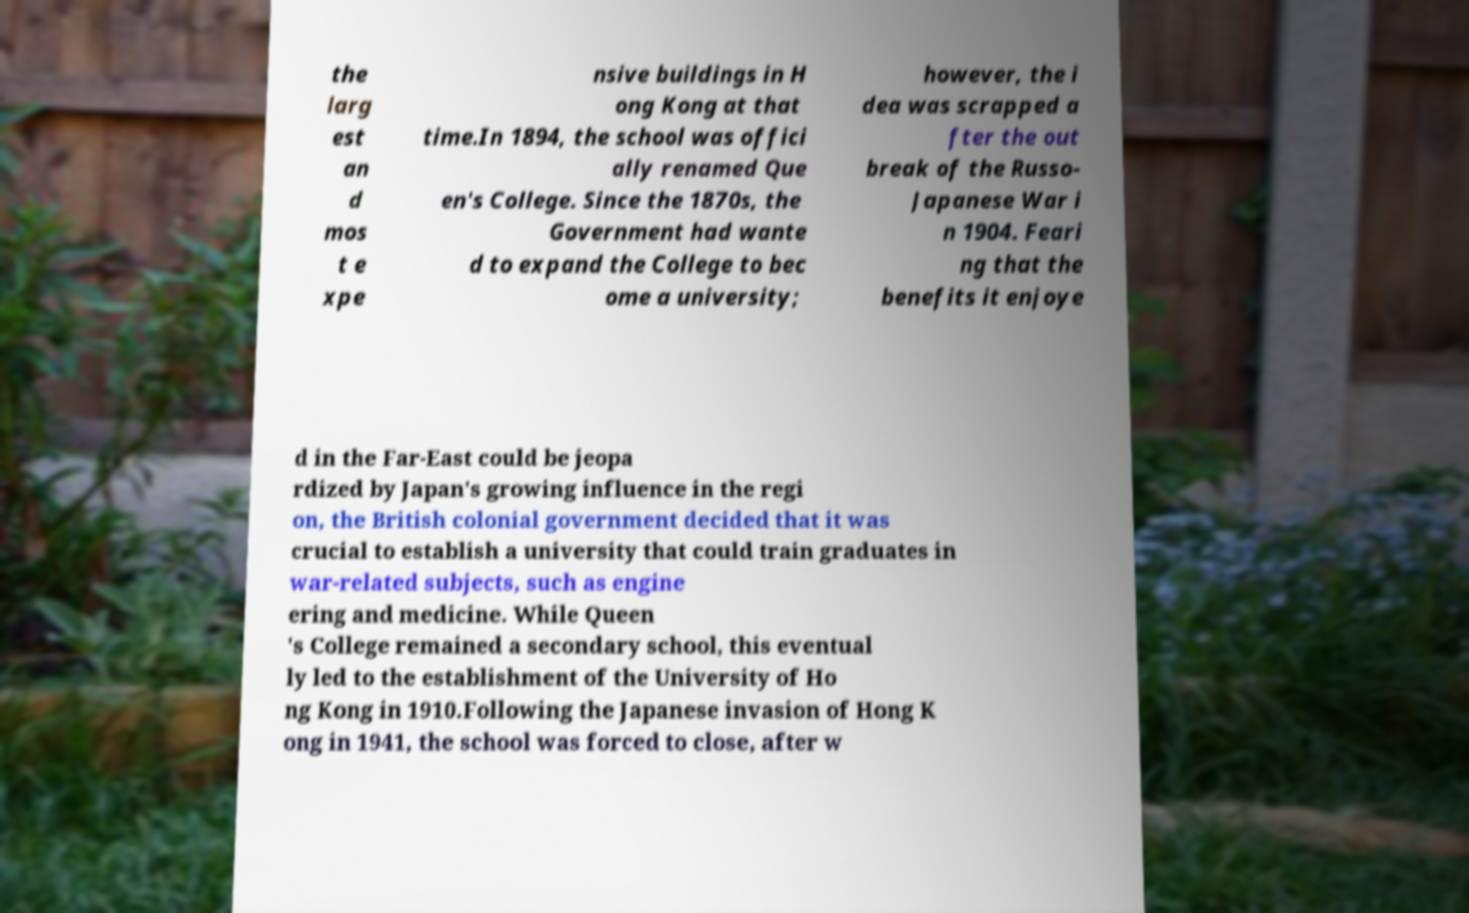What messages or text are displayed in this image? I need them in a readable, typed format. the larg est an d mos t e xpe nsive buildings in H ong Kong at that time.In 1894, the school was offici ally renamed Que en's College. Since the 1870s, the Government had wante d to expand the College to bec ome a university; however, the i dea was scrapped a fter the out break of the Russo- Japanese War i n 1904. Feari ng that the benefits it enjoye d in the Far-East could be jeopa rdized by Japan's growing influence in the regi on, the British colonial government decided that it was crucial to establish a university that could train graduates in war-related subjects, such as engine ering and medicine. While Queen 's College remained a secondary school, this eventual ly led to the establishment of the University of Ho ng Kong in 1910.Following the Japanese invasion of Hong K ong in 1941, the school was forced to close, after w 